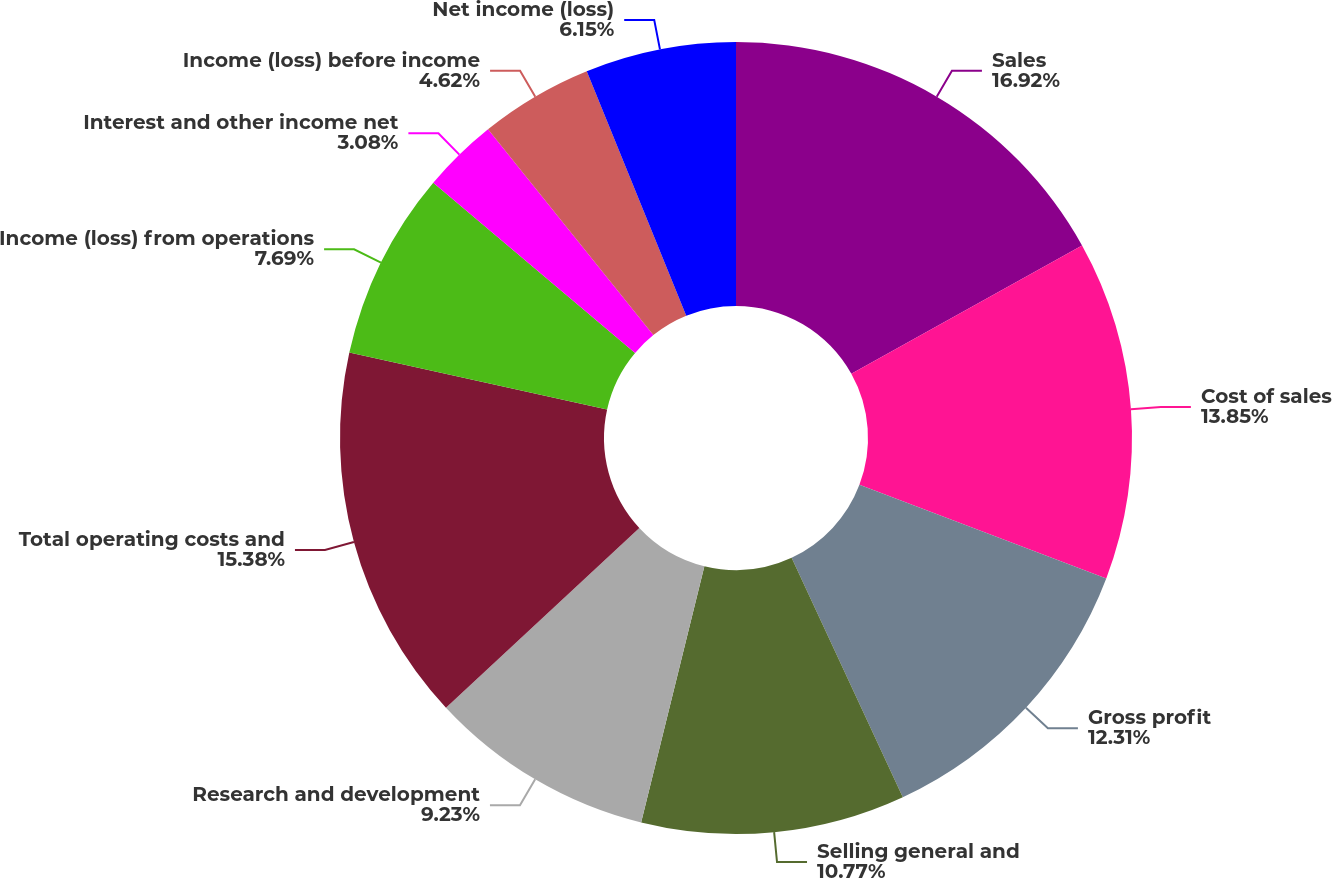<chart> <loc_0><loc_0><loc_500><loc_500><pie_chart><fcel>Sales<fcel>Cost of sales<fcel>Gross profit<fcel>Selling general and<fcel>Research and development<fcel>Total operating costs and<fcel>Income (loss) from operations<fcel>Interest and other income net<fcel>Income (loss) before income<fcel>Net income (loss)<nl><fcel>16.92%<fcel>13.85%<fcel>12.31%<fcel>10.77%<fcel>9.23%<fcel>15.38%<fcel>7.69%<fcel>3.08%<fcel>4.62%<fcel>6.15%<nl></chart> 